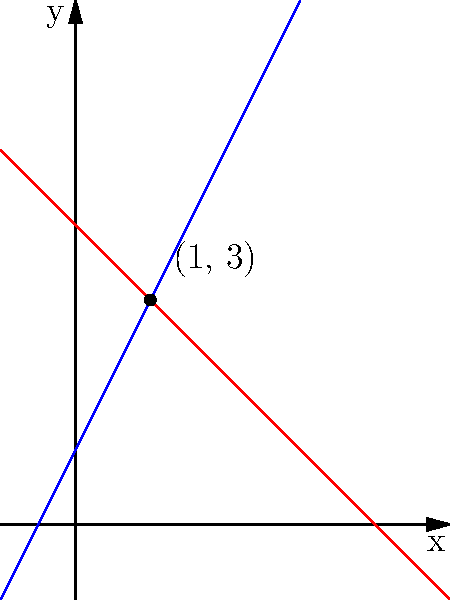As a senior manager overseeing the public relations department, you're analyzing the performance of two marketing campaigns. Campaign A's reach can be modeled by the equation $y = 2x + 1$, while Campaign B's reach is represented by $y = -x + 4$, where $x$ is the time in weeks and $y$ is the reach in millions. At what point do these campaigns intersect, and what does this mean for your PR strategy? To find the intersection point of these two lines, we need to solve the system of equations:

$$\begin{cases}
y = 2x + 1 \\
y = -x + 4
\end{cases}$$

Step 1: Set the equations equal to each other since they intersect at a point where y-values are the same.
$2x + 1 = -x + 4$

Step 2: Solve for x.
$2x + 1 = -x + 4$
$3x = 3$
$x = 1$

Step 3: Substitute x = 1 into either equation to find y.
Using $y = 2x + 1$:
$y = 2(1) + 1 = 3$

Therefore, the intersection point is (1, 3).

This means that after 1 week, both campaigns will have reached 3 million people. For your PR strategy, this indicates that Campaign A (with a steeper slope) will outperform Campaign B after the first week, while Campaign B had a higher initial reach but slower growth.
Answer: (1, 3); After 1 week, both campaigns reach 3 million people. Campaign A outperforms B thereafter. 